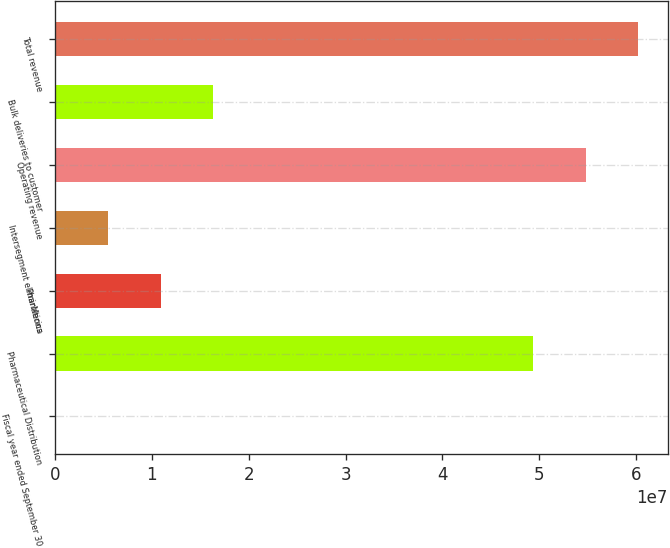<chart> <loc_0><loc_0><loc_500><loc_500><bar_chart><fcel>Fiscal year ended September 30<fcel>Pharmaceutical Distribution<fcel>PharMerica<fcel>Intersegment eliminations<fcel>Operating revenue<fcel>Bulk deliveries to customer<fcel>Total revenue<nl><fcel>2005<fcel>4.93194e+07<fcel>1.09171e+07<fcel>5.45954e+06<fcel>5.47769e+07<fcel>1.63746e+07<fcel>6.02344e+07<nl></chart> 